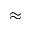<formula> <loc_0><loc_0><loc_500><loc_500>\approx</formula> 